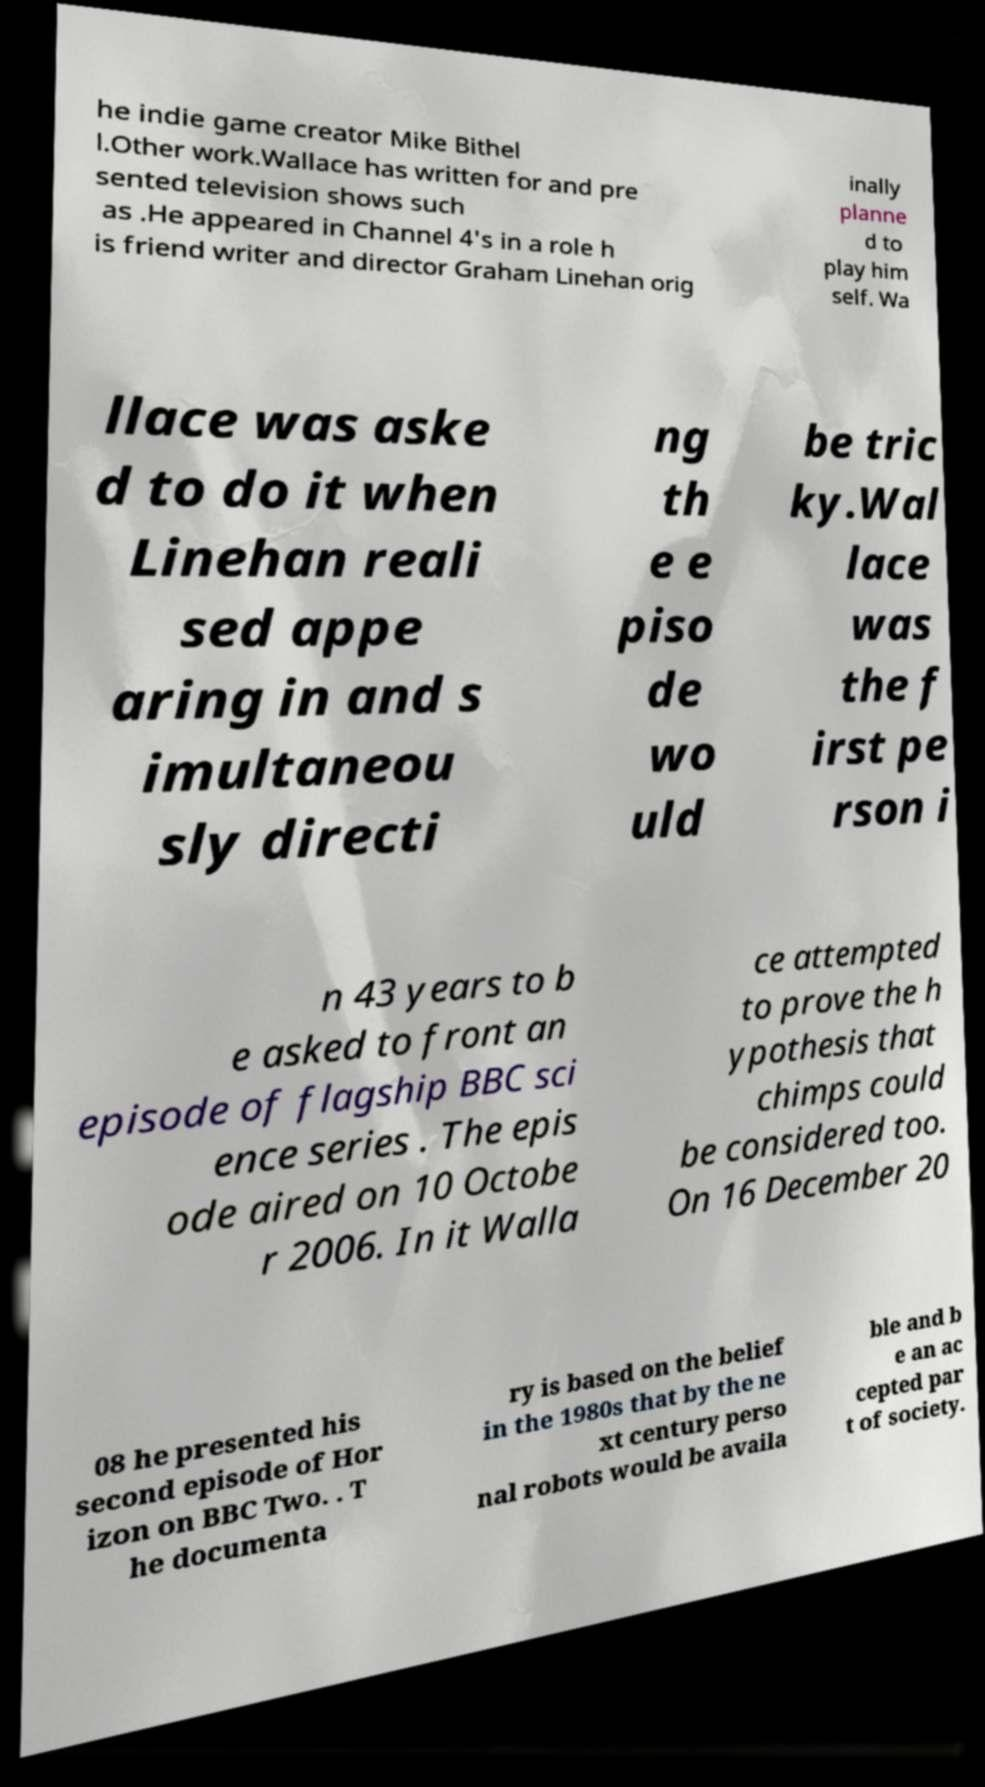Could you assist in decoding the text presented in this image and type it out clearly? he indie game creator Mike Bithel l.Other work.Wallace has written for and pre sented television shows such as .He appeared in Channel 4's in a role h is friend writer and director Graham Linehan orig inally planne d to play him self. Wa llace was aske d to do it when Linehan reali sed appe aring in and s imultaneou sly directi ng th e e piso de wo uld be tric ky.Wal lace was the f irst pe rson i n 43 years to b e asked to front an episode of flagship BBC sci ence series . The epis ode aired on 10 Octobe r 2006. In it Walla ce attempted to prove the h ypothesis that chimps could be considered too. On 16 December 20 08 he presented his second episode of Hor izon on BBC Two. . T he documenta ry is based on the belief in the 1980s that by the ne xt century perso nal robots would be availa ble and b e an ac cepted par t of society. 